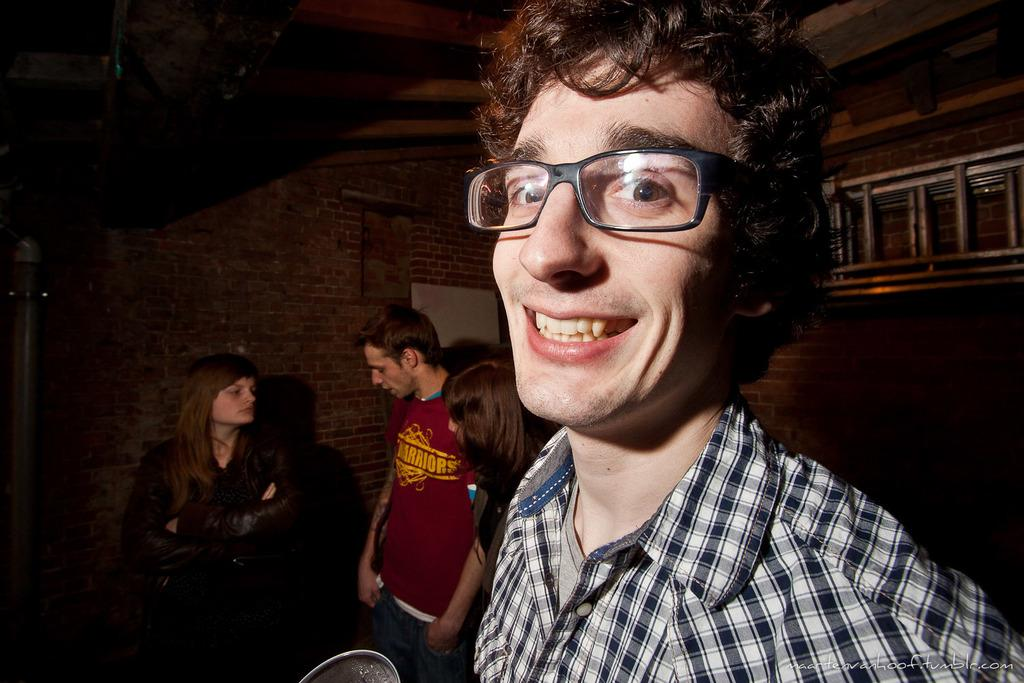Who or what can be seen in the image? There are people in the image. What is the background of the image? There is a wall visible in the image. What object is present in the image that can be used for climbing? There is a ladder in the image. What part of a building can be seen at the top of the image? The roof is visible at the top of the image. What type of pain is being experienced by the rail in the image? There is no rail present in the image, and therefore no pain can be associated with it. 